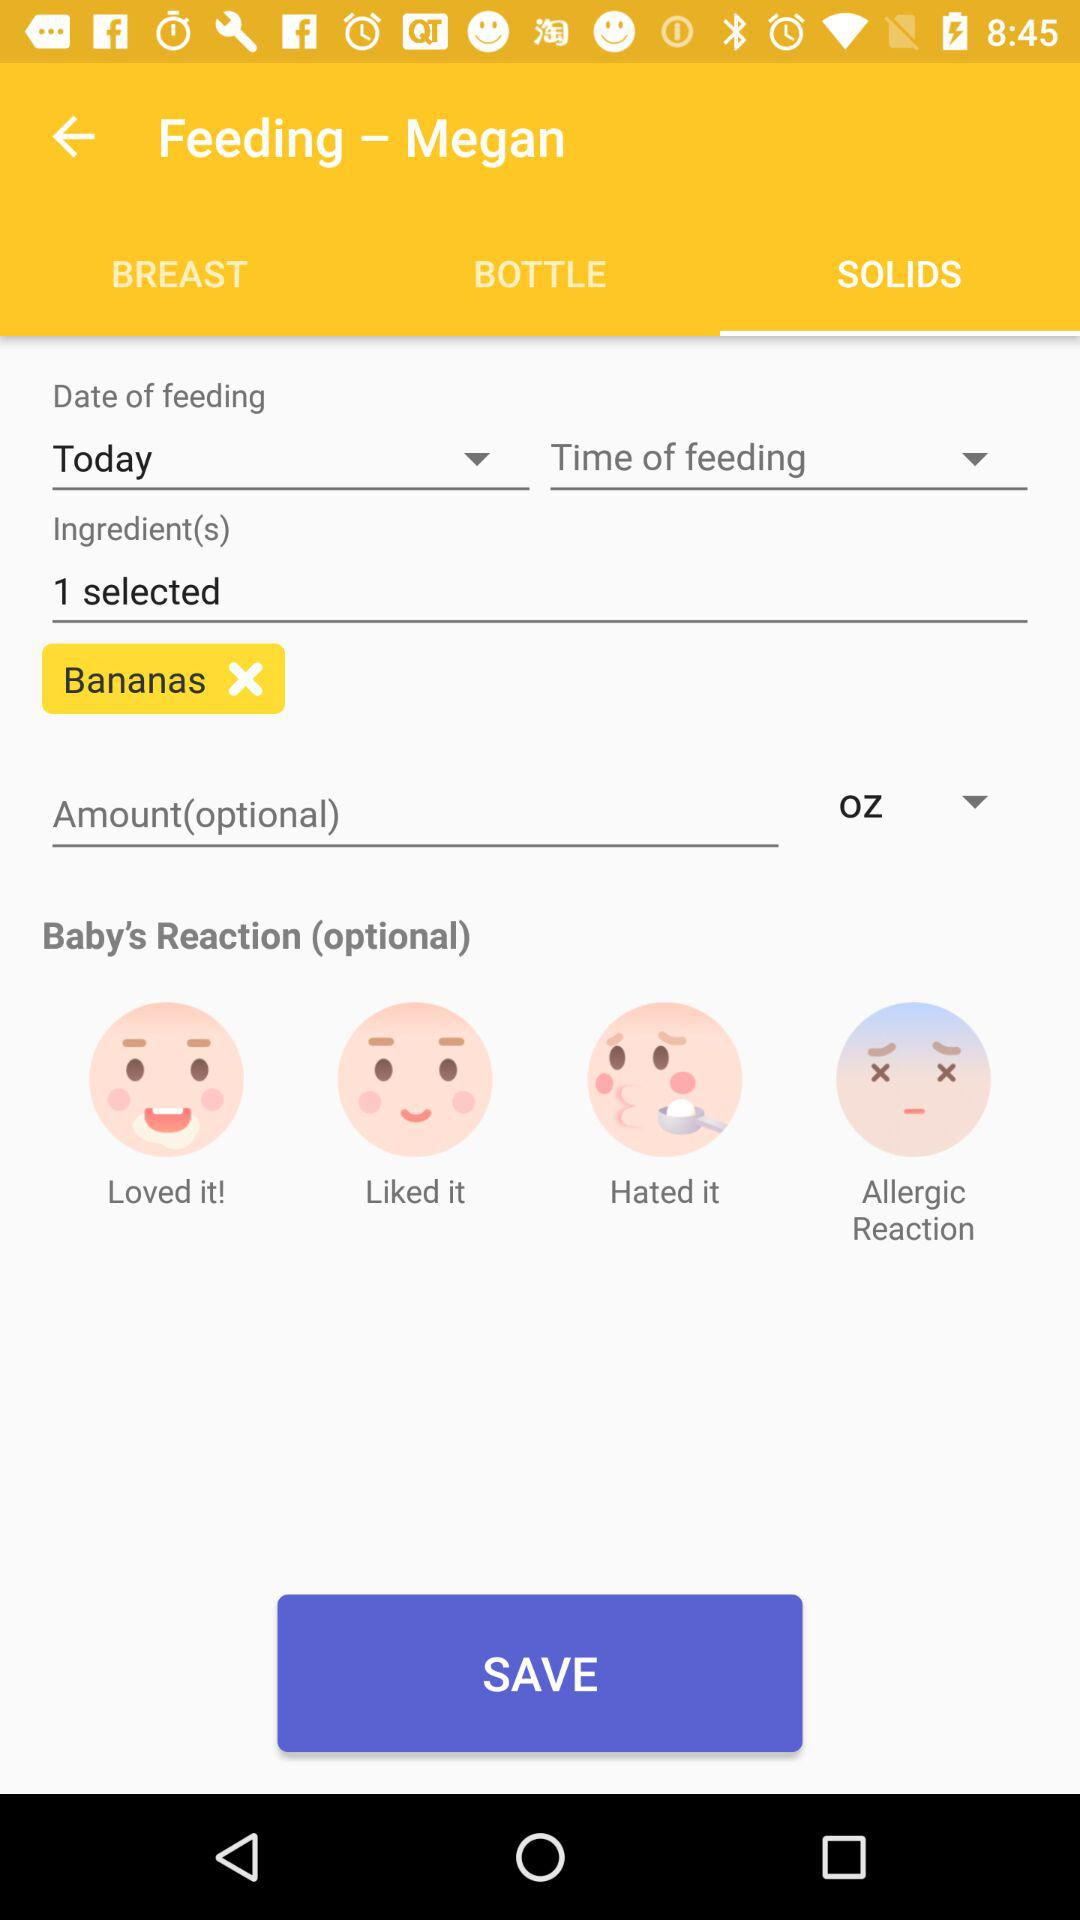Which types of baby reactions are there? The types of baby reactions are "Loved it!", "Liked it", "Hated it" and "Allergic Reaction". 